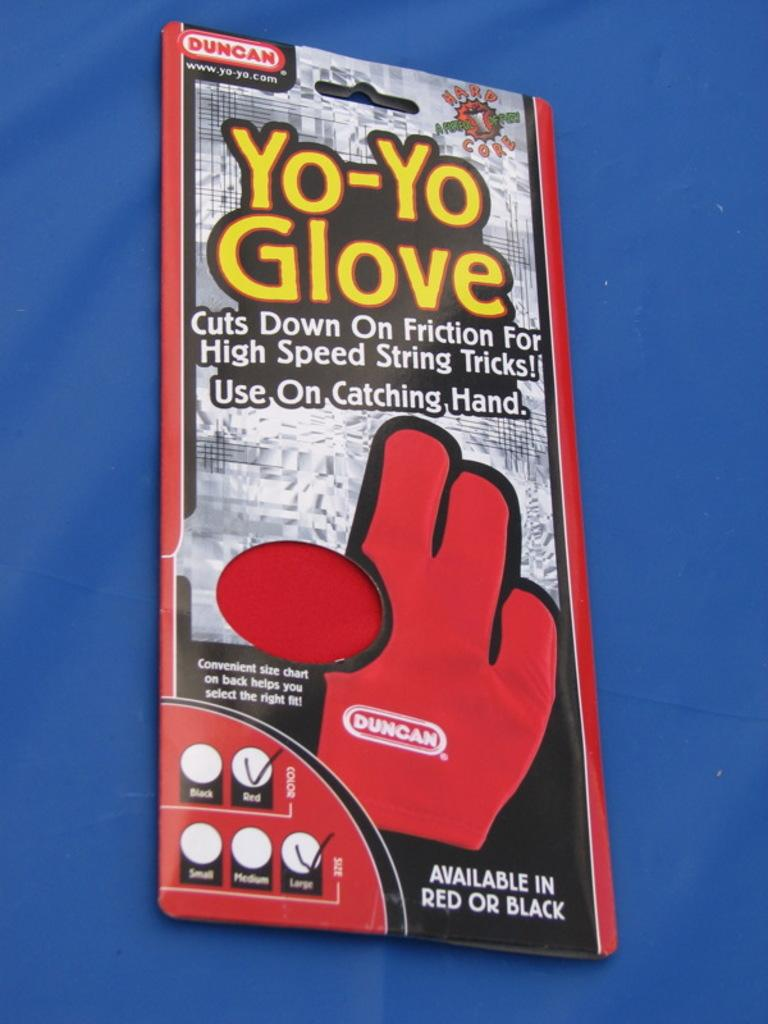What is the main object in the foreground of the image? There is a sachet in the foreground of the image. What color is the surface on which the sachet is placed? The sachet is on a blue surface. What type of dress is the person wearing in the image? There is no person or dress present in the image; it only features a sachet on a blue surface. 